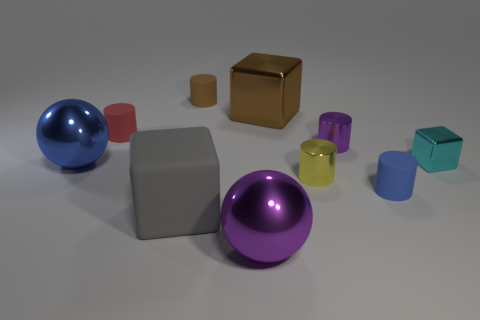What number of blue metal objects are right of the purple object behind the purple sphere?
Give a very brief answer. 0. What size is the cylinder that is on the left side of the large matte block in front of the blue object that is on the right side of the tiny brown cylinder?
Make the answer very short. Small. Does the cylinder that is behind the big brown object have the same color as the big metal cube?
Your response must be concise. Yes. What size is the cyan metallic object that is the same shape as the big brown thing?
Offer a terse response. Small. How many objects are either blue rubber cylinders that are on the right side of the large gray rubber block or objects behind the tiny blue thing?
Provide a succinct answer. 8. There is a purple object that is in front of the big block that is in front of the tiny cyan cube; what shape is it?
Your answer should be compact. Sphere. Is there anything else that has the same color as the tiny block?
Your response must be concise. No. How many objects are either big gray objects or tiny yellow things?
Ensure brevity in your answer.  2. Are there any blue cylinders that have the same size as the purple shiny cylinder?
Ensure brevity in your answer.  Yes. What is the shape of the gray matte object?
Offer a terse response. Cube. 